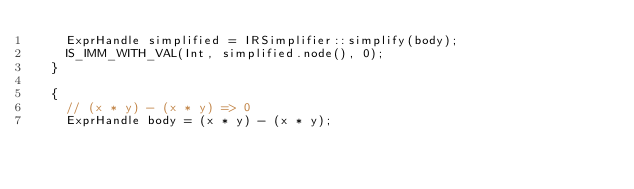Convert code to text. <code><loc_0><loc_0><loc_500><loc_500><_C++_>    ExprHandle simplified = IRSimplifier::simplify(body);
    IS_IMM_WITH_VAL(Int, simplified.node(), 0);
  }

  {
    // (x * y) - (x * y) => 0
    ExprHandle body = (x * y) - (x * y);</code> 